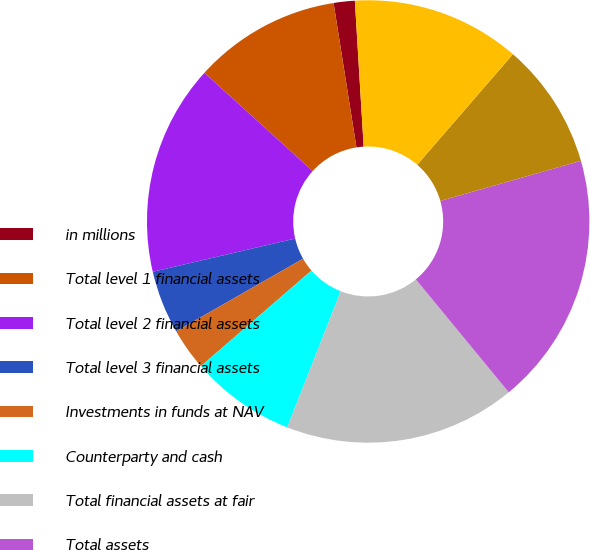Convert chart to OTSL. <chart><loc_0><loc_0><loc_500><loc_500><pie_chart><fcel>in millions<fcel>Total level 1 financial assets<fcel>Total level 2 financial assets<fcel>Total level 3 financial assets<fcel>Investments in funds at NAV<fcel>Counterparty and cash<fcel>Total financial assets at fair<fcel>Total assets<fcel>Total level 1 financial<fcel>Total level 2 financial<nl><fcel>1.54%<fcel>10.77%<fcel>15.38%<fcel>4.62%<fcel>3.08%<fcel>7.69%<fcel>16.92%<fcel>18.46%<fcel>9.23%<fcel>12.31%<nl></chart> 